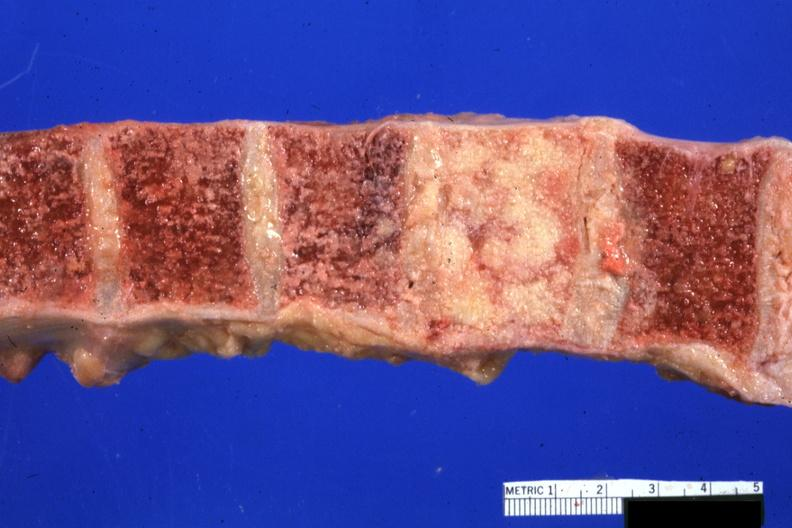how does this image show vertebral bodies?
Answer the question using a single word or phrase. With one completely replaced by neoplasm excellent photo 68yowm cord compression 